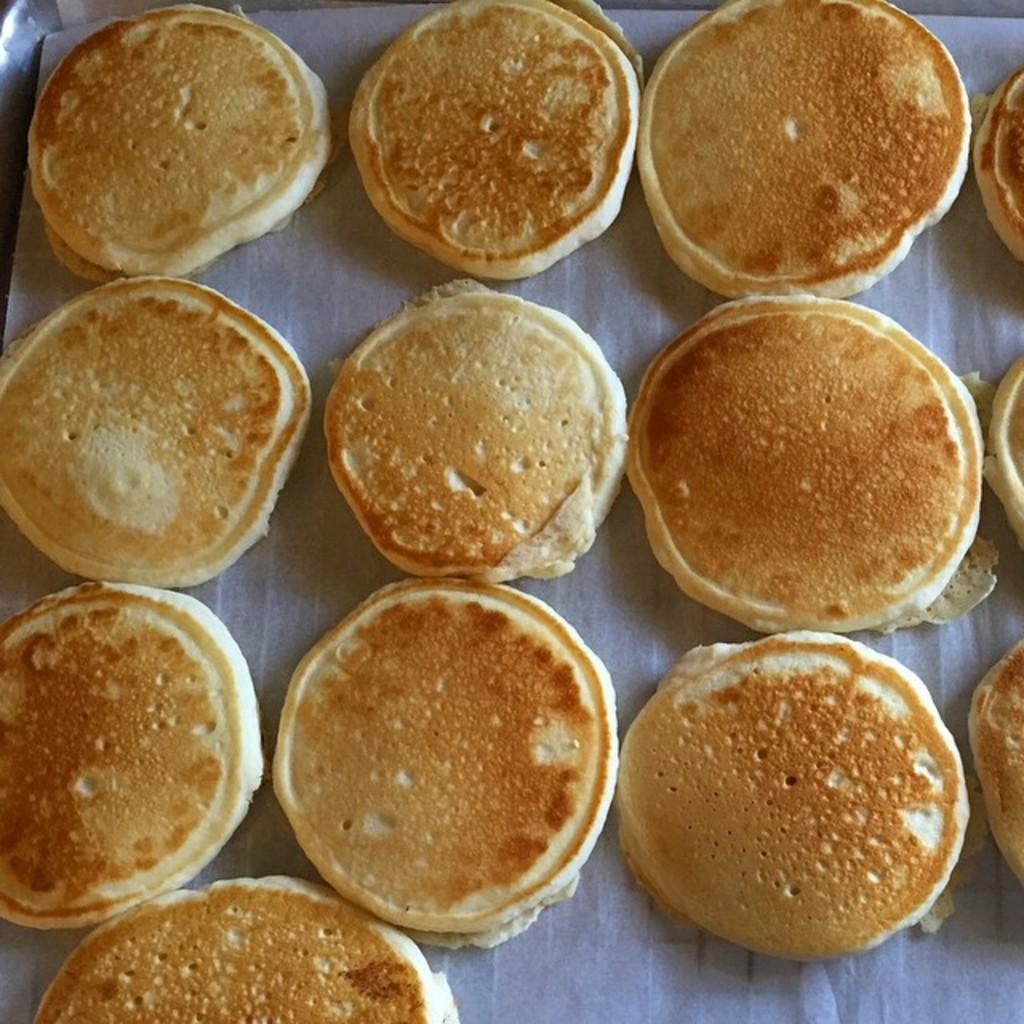What is the main subject of the image? The main subject of the image is food. Where is the food located in the image? The food is in the center of the image. What type of face can be seen on the food in the image? There is no face visible on the food in the image. 